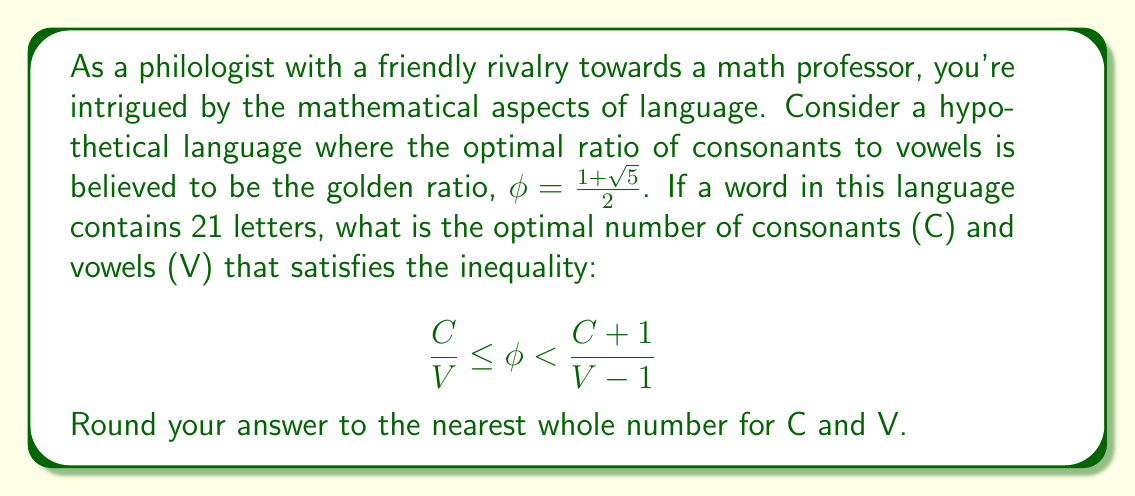Could you help me with this problem? Let's approach this step-by-step:

1) We know that $\phi = \frac{1+\sqrt{5}}{2} \approx 1.618034$

2) The total number of letters is 21, so $C + V = 21$

3) We need to find C and V that satisfy:

   $$ \frac{C}{V} \leq \phi < \frac{C+1}{V-1} $$

4) Let's start with the left inequality: $\frac{C}{V} \leq \phi$
   
   Multiplying both sides by V: $C \leq \phi V$

5) Now, substitute $V = 21 - C$ (from step 2):
   
   $C \leq \phi (21 - C)$
   $C \leq 21\phi - C\phi$
   $C + C\phi \leq 21\phi$
   $C(1 + \phi) \leq 21\phi$
   $C \leq \frac{21\phi}{1+\phi}$

6) Calculating this:
   $C \leq \frac{21 \cdot 1.618034}{1 + 1.618034} \approx 12.99$

7) The largest integer C that satisfies this is 12. This gives V = 9.

8) Now let's check if this satisfies the right inequality:

   $\phi < \frac{C+1}{V-1}$
   $1.618034 < \frac{13}{8} = 1.625$

9) This is indeed satisfied. Therefore, the optimal distribution is 12 consonants and 9 vowels.
Answer: The optimal distribution is 12 consonants (C) and 9 vowels (V). 